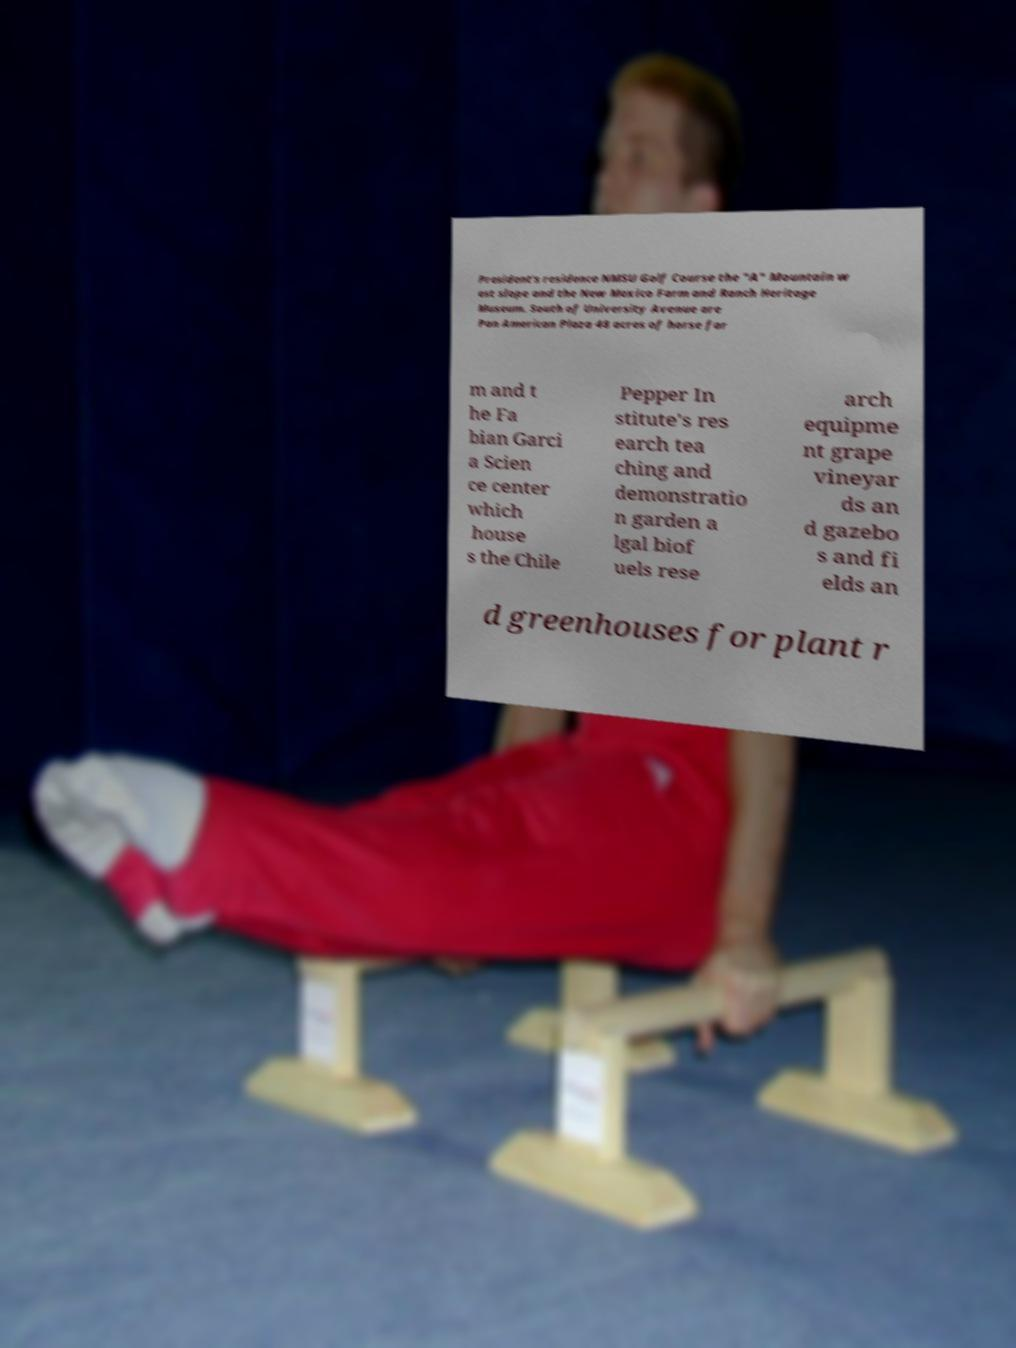There's text embedded in this image that I need extracted. Can you transcribe it verbatim? President's residence NMSU Golf Course the "A" Mountain w est slope and the New Mexico Farm and Ranch Heritage Museum. South of University Avenue are Pan American Plaza 48 acres of horse far m and t he Fa bian Garci a Scien ce center which house s the Chile Pepper In stitute's res earch tea ching and demonstratio n garden a lgal biof uels rese arch equipme nt grape vineyar ds an d gazebo s and fi elds an d greenhouses for plant r 